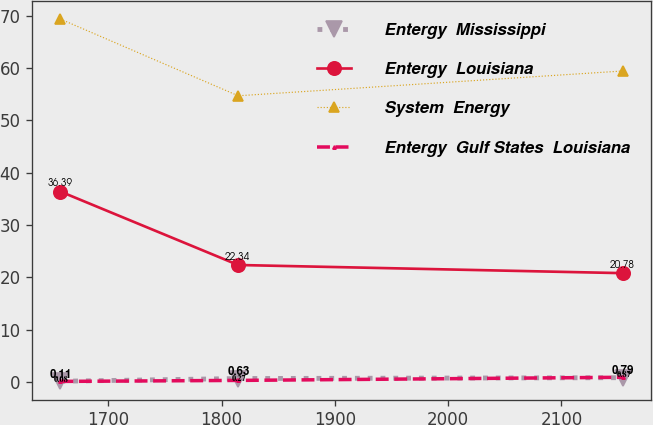Convert chart to OTSL. <chart><loc_0><loc_0><loc_500><loc_500><line_chart><ecel><fcel>Entergy  Mississippi<fcel>Entergy  Louisiana<fcel>System  Energy<fcel>Entergy  Gulf States  Louisiana<nl><fcel>1657.58<fcel>0.11<fcel>36.39<fcel>69.37<fcel>0.08<nl><fcel>1814.55<fcel>0.63<fcel>22.34<fcel>54.7<fcel>0.27<nl><fcel>2154.27<fcel>0.79<fcel>20.78<fcel>59.44<fcel>0.87<nl></chart> 